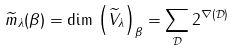Convert formula to latex. <formula><loc_0><loc_0><loc_500><loc_500>\widetilde { m } _ { \lambda } ( \beta ) = \dim \, { \left ( \widetilde { V } _ { \lambda } \right ) } _ { \beta } = \sum _ { \mathcal { D } } 2 ^ { \nabla ( \mathcal { D } ) }</formula> 